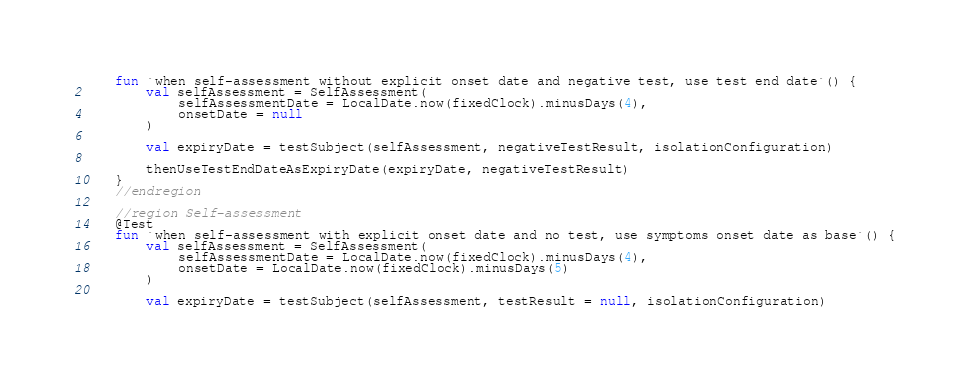<code> <loc_0><loc_0><loc_500><loc_500><_Kotlin_>    fun `when self-assessment without explicit onset date and negative test, use test end date`() {
        val selfAssessment = SelfAssessment(
            selfAssessmentDate = LocalDate.now(fixedClock).minusDays(4),
            onsetDate = null
        )

        val expiryDate = testSubject(selfAssessment, negativeTestResult, isolationConfiguration)

        thenUseTestEndDateAsExpiryDate(expiryDate, negativeTestResult)
    }
    //endregion

    //region Self-assessment
    @Test
    fun `when self-assessment with explicit onset date and no test, use symptoms onset date as base`() {
        val selfAssessment = SelfAssessment(
            selfAssessmentDate = LocalDate.now(fixedClock).minusDays(4),
            onsetDate = LocalDate.now(fixedClock).minusDays(5)
        )

        val expiryDate = testSubject(selfAssessment, testResult = null, isolationConfiguration)
</code> 